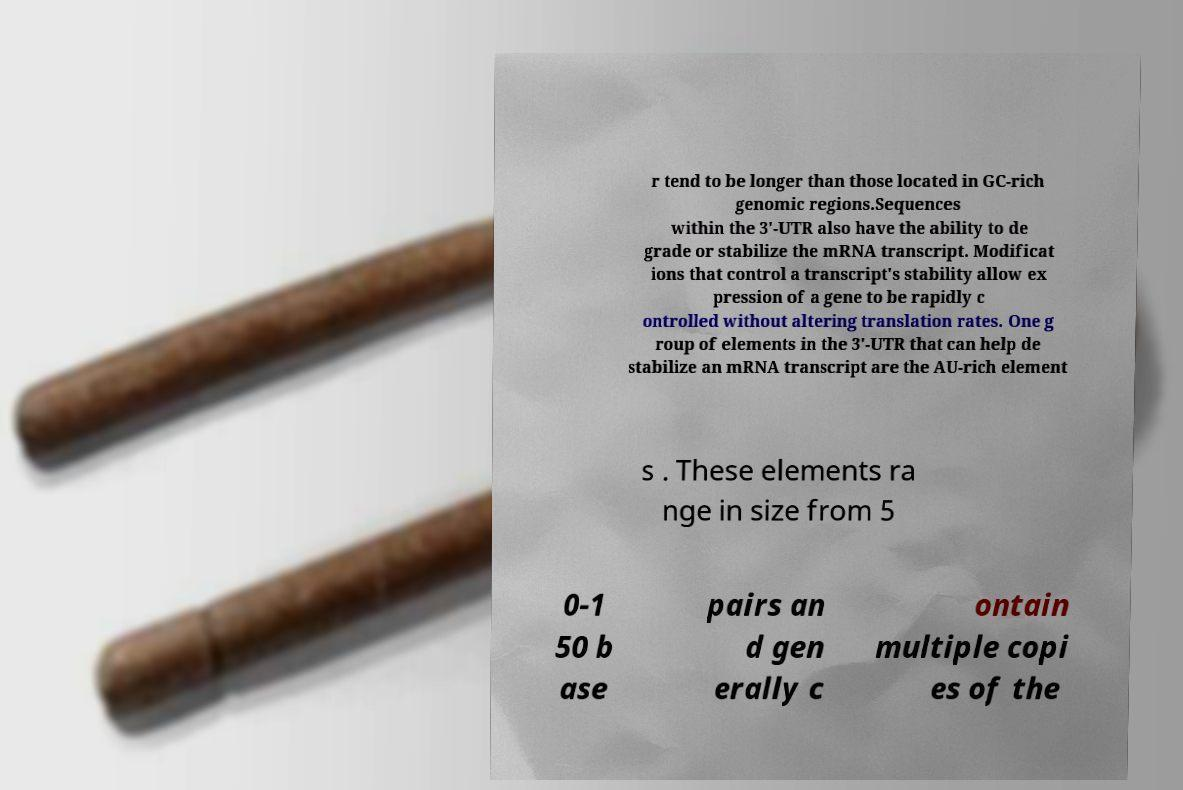Could you extract and type out the text from this image? r tend to be longer than those located in GC-rich genomic regions.Sequences within the 3′-UTR also have the ability to de grade or stabilize the mRNA transcript. Modificat ions that control a transcript's stability allow ex pression of a gene to be rapidly c ontrolled without altering translation rates. One g roup of elements in the 3′-UTR that can help de stabilize an mRNA transcript are the AU-rich element s . These elements ra nge in size from 5 0-1 50 b ase pairs an d gen erally c ontain multiple copi es of the 